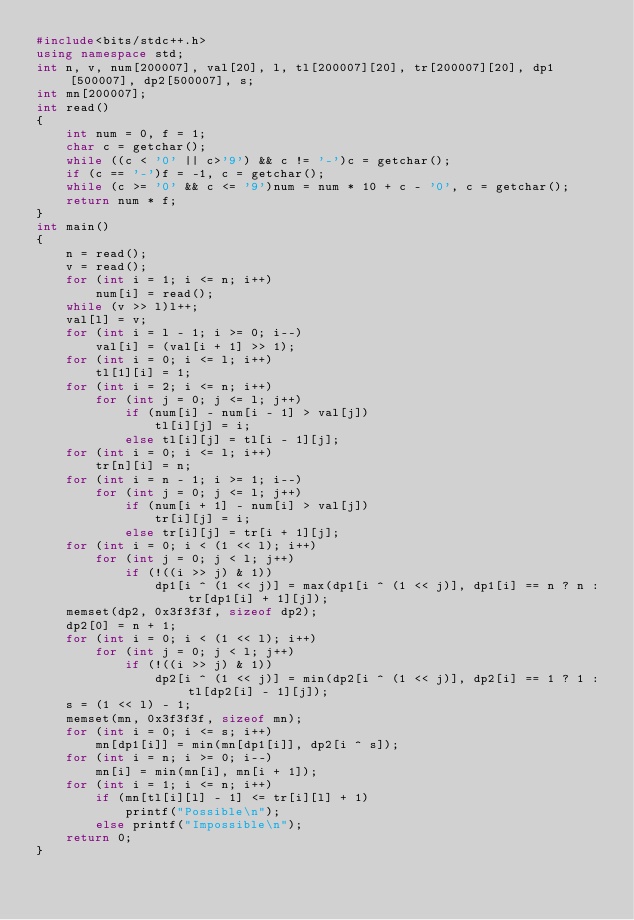<code> <loc_0><loc_0><loc_500><loc_500><_C++_>#include<bits/stdc++.h>
using namespace std;
int n, v, num[200007], val[20], l, tl[200007][20], tr[200007][20], dp1[500007], dp2[500007], s;
int mn[200007];
int read()
{
	int num = 0, f = 1;
	char c = getchar();
	while ((c < '0' || c>'9') && c != '-')c = getchar();
	if (c == '-')f = -1, c = getchar();
	while (c >= '0' && c <= '9')num = num * 10 + c - '0', c = getchar();
	return num * f;
}
int main()
{
	n = read();
	v = read();
	for (int i = 1; i <= n; i++)
		num[i] = read();
	while (v >> l)l++;
	val[l] = v;
	for (int i = l - 1; i >= 0; i--)
		val[i] = (val[i + 1] >> 1);
	for (int i = 0; i <= l; i++)
		tl[1][i] = 1;
	for (int i = 2; i <= n; i++)
		for (int j = 0; j <= l; j++)
			if (num[i] - num[i - 1] > val[j])
				tl[i][j] = i;
			else tl[i][j] = tl[i - 1][j];
	for (int i = 0; i <= l; i++)
		tr[n][i] = n;
	for (int i = n - 1; i >= 1; i--)
		for (int j = 0; j <= l; j++)
			if (num[i + 1] - num[i] > val[j])
				tr[i][j] = i;
			else tr[i][j] = tr[i + 1][j];
	for (int i = 0; i < (1 << l); i++)
		for (int j = 0; j < l; j++)
			if (!((i >> j) & 1))
				dp1[i ^ (1 << j)] = max(dp1[i ^ (1 << j)], dp1[i] == n ? n : tr[dp1[i] + 1][j]);
	memset(dp2, 0x3f3f3f, sizeof dp2);
	dp2[0] = n + 1;
	for (int i = 0; i < (1 << l); i++)
		for (int j = 0; j < l; j++)
			if (!((i >> j) & 1))
				dp2[i ^ (1 << j)] = min(dp2[i ^ (1 << j)], dp2[i] == 1 ? 1 : tl[dp2[i] - 1][j]);
	s = (1 << l) - 1;
	memset(mn, 0x3f3f3f, sizeof mn);
	for (int i = 0; i <= s; i++)
		mn[dp1[i]] = min(mn[dp1[i]], dp2[i ^ s]);
	for (int i = n; i >= 0; i--)
		mn[i] = min(mn[i], mn[i + 1]);
	for (int i = 1; i <= n; i++)
		if (mn[tl[i][l] - 1] <= tr[i][l] + 1)
			printf("Possible\n");
		else printf("Impossible\n");
	return 0;
}</code> 